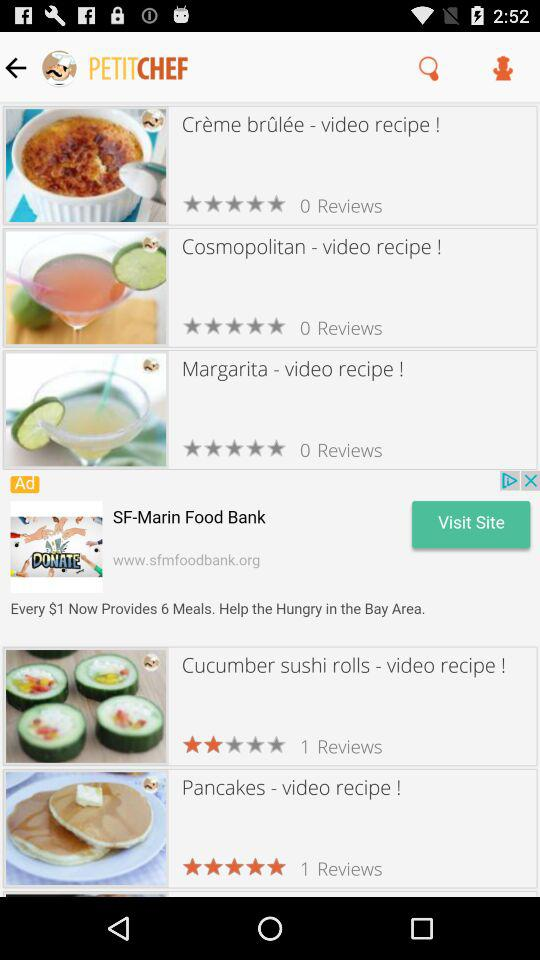What is the rating for "Pancakes"? The rating is 5 stars. 